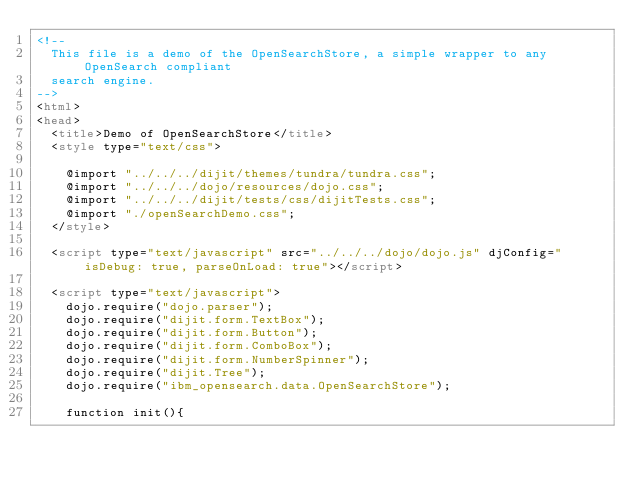Convert code to text. <code><loc_0><loc_0><loc_500><loc_500><_HTML_><!--
  This file is a demo of the OpenSearchStore, a simple wrapper to any OpenSearch compliant
  search engine.
-->
<html>
<head>
	<title>Demo of OpenSearchStore</title>
	<style type="text/css">

		@import "../../../dijit/themes/tundra/tundra.css";
		@import "../../../dojo/resources/dojo.css";
		@import "../../../dijit/tests/css/dijitTests.css";
		@import "./openSearchDemo.css";
	</style>

	<script type="text/javascript" src="../../../dojo/dojo.js" djConfig="isDebug: true, parseOnLoad: true"></script>
	
	<script type="text/javascript">
		dojo.require("dojo.parser");
		dojo.require("dijit.form.TextBox");
		dojo.require("dijit.form.Button");
		dojo.require("dijit.form.ComboBox");
		dojo.require("dijit.form.NumberSpinner");
		dojo.require("dijit.Tree");
		dojo.require("ibm_opensearch.data.OpenSearchStore");

		function init(){</code> 